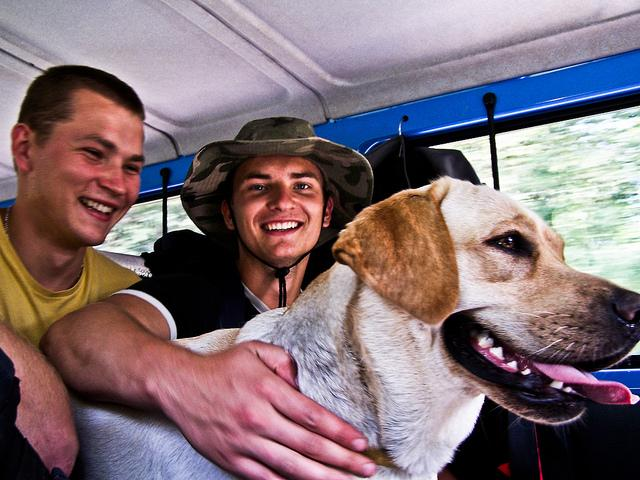What is touching the dog?

Choices:
A) cat's paw
B) man's hand
C) bear's claw
D) woman's hand man's hand 